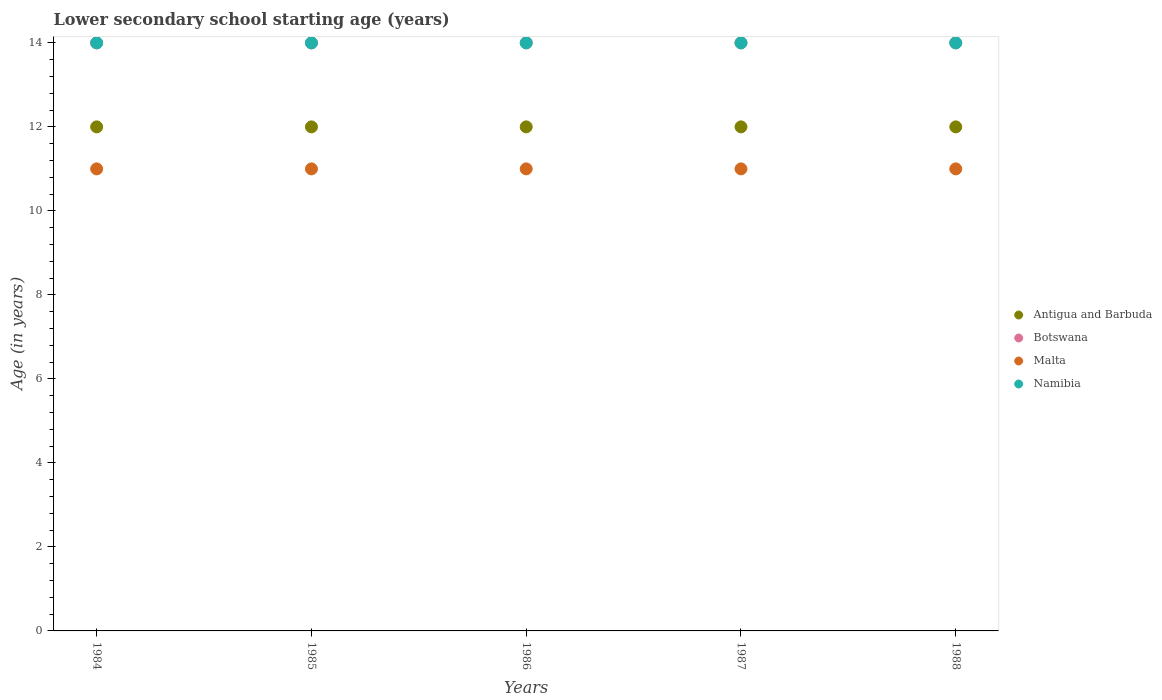Is the number of dotlines equal to the number of legend labels?
Offer a terse response. Yes. Across all years, what is the maximum lower secondary school starting age of children in Botswana?
Your answer should be compact. 14. Across all years, what is the minimum lower secondary school starting age of children in Antigua and Barbuda?
Your answer should be compact. 12. In which year was the lower secondary school starting age of children in Botswana minimum?
Make the answer very short. 1984. What is the total lower secondary school starting age of children in Botswana in the graph?
Your response must be concise. 70. What is the difference between the lower secondary school starting age of children in Botswana in 1985 and that in 1988?
Your answer should be very brief. 0. What is the difference between the lower secondary school starting age of children in Malta in 1984 and the lower secondary school starting age of children in Namibia in 1988?
Offer a terse response. -3. In the year 1988, what is the difference between the lower secondary school starting age of children in Botswana and lower secondary school starting age of children in Namibia?
Offer a very short reply. 0. Is the lower secondary school starting age of children in Botswana in 1984 less than that in 1985?
Ensure brevity in your answer.  No. Is the difference between the lower secondary school starting age of children in Botswana in 1986 and 1987 greater than the difference between the lower secondary school starting age of children in Namibia in 1986 and 1987?
Provide a short and direct response. No. In how many years, is the lower secondary school starting age of children in Namibia greater than the average lower secondary school starting age of children in Namibia taken over all years?
Your answer should be very brief. 0. Is the sum of the lower secondary school starting age of children in Malta in 1987 and 1988 greater than the maximum lower secondary school starting age of children in Botswana across all years?
Your response must be concise. Yes. Is it the case that in every year, the sum of the lower secondary school starting age of children in Malta and lower secondary school starting age of children in Botswana  is greater than the lower secondary school starting age of children in Antigua and Barbuda?
Your answer should be compact. Yes. Is the lower secondary school starting age of children in Malta strictly greater than the lower secondary school starting age of children in Botswana over the years?
Your response must be concise. No. How many dotlines are there?
Offer a very short reply. 4. How many years are there in the graph?
Your answer should be compact. 5. Does the graph contain any zero values?
Keep it short and to the point. No. Does the graph contain grids?
Offer a very short reply. No. Where does the legend appear in the graph?
Your answer should be very brief. Center right. How many legend labels are there?
Your answer should be compact. 4. What is the title of the graph?
Your answer should be very brief. Lower secondary school starting age (years). What is the label or title of the X-axis?
Provide a succinct answer. Years. What is the label or title of the Y-axis?
Make the answer very short. Age (in years). What is the Age (in years) in Botswana in 1984?
Your answer should be compact. 14. What is the Age (in years) of Malta in 1984?
Ensure brevity in your answer.  11. What is the Age (in years) in Namibia in 1984?
Your response must be concise. 14. What is the Age (in years) in Malta in 1985?
Provide a short and direct response. 11. What is the Age (in years) of Namibia in 1985?
Make the answer very short. 14. What is the Age (in years) of Antigua and Barbuda in 1986?
Offer a very short reply. 12. What is the Age (in years) in Botswana in 1986?
Offer a very short reply. 14. What is the Age (in years) in Malta in 1986?
Offer a terse response. 11. What is the Age (in years) in Namibia in 1986?
Offer a terse response. 14. What is the Age (in years) of Antigua and Barbuda in 1987?
Ensure brevity in your answer.  12. What is the Age (in years) in Namibia in 1987?
Ensure brevity in your answer.  14. What is the Age (in years) of Antigua and Barbuda in 1988?
Give a very brief answer. 12. What is the Age (in years) in Namibia in 1988?
Give a very brief answer. 14. Across all years, what is the maximum Age (in years) in Malta?
Your response must be concise. 11. Across all years, what is the maximum Age (in years) of Namibia?
Ensure brevity in your answer.  14. Across all years, what is the minimum Age (in years) in Antigua and Barbuda?
Ensure brevity in your answer.  12. Across all years, what is the minimum Age (in years) of Botswana?
Ensure brevity in your answer.  14. What is the total Age (in years) in Antigua and Barbuda in the graph?
Your answer should be compact. 60. What is the total Age (in years) of Botswana in the graph?
Ensure brevity in your answer.  70. What is the difference between the Age (in years) in Malta in 1984 and that in 1986?
Give a very brief answer. 0. What is the difference between the Age (in years) in Namibia in 1984 and that in 1986?
Offer a terse response. 0. What is the difference between the Age (in years) of Malta in 1984 and that in 1987?
Provide a short and direct response. 0. What is the difference between the Age (in years) in Namibia in 1984 and that in 1987?
Offer a very short reply. 0. What is the difference between the Age (in years) in Namibia in 1984 and that in 1988?
Provide a succinct answer. 0. What is the difference between the Age (in years) of Botswana in 1985 and that in 1986?
Give a very brief answer. 0. What is the difference between the Age (in years) of Antigua and Barbuda in 1985 and that in 1987?
Offer a very short reply. 0. What is the difference between the Age (in years) of Malta in 1985 and that in 1987?
Give a very brief answer. 0. What is the difference between the Age (in years) of Antigua and Barbuda in 1985 and that in 1988?
Ensure brevity in your answer.  0. What is the difference between the Age (in years) in Antigua and Barbuda in 1986 and that in 1987?
Offer a very short reply. 0. What is the difference between the Age (in years) of Botswana in 1986 and that in 1987?
Your answer should be compact. 0. What is the difference between the Age (in years) in Namibia in 1986 and that in 1987?
Give a very brief answer. 0. What is the difference between the Age (in years) in Antigua and Barbuda in 1986 and that in 1988?
Provide a succinct answer. 0. What is the difference between the Age (in years) of Botswana in 1986 and that in 1988?
Give a very brief answer. 0. What is the difference between the Age (in years) in Botswana in 1987 and that in 1988?
Keep it short and to the point. 0. What is the difference between the Age (in years) in Malta in 1987 and that in 1988?
Make the answer very short. 0. What is the difference between the Age (in years) of Antigua and Barbuda in 1984 and the Age (in years) of Botswana in 1985?
Provide a succinct answer. -2. What is the difference between the Age (in years) of Antigua and Barbuda in 1984 and the Age (in years) of Namibia in 1985?
Offer a terse response. -2. What is the difference between the Age (in years) in Botswana in 1984 and the Age (in years) in Malta in 1985?
Give a very brief answer. 3. What is the difference between the Age (in years) in Malta in 1984 and the Age (in years) in Namibia in 1985?
Your answer should be very brief. -3. What is the difference between the Age (in years) of Antigua and Barbuda in 1984 and the Age (in years) of Botswana in 1986?
Your response must be concise. -2. What is the difference between the Age (in years) of Antigua and Barbuda in 1984 and the Age (in years) of Malta in 1986?
Your answer should be very brief. 1. What is the difference between the Age (in years) in Antigua and Barbuda in 1984 and the Age (in years) in Namibia in 1986?
Make the answer very short. -2. What is the difference between the Age (in years) of Botswana in 1984 and the Age (in years) of Namibia in 1986?
Provide a succinct answer. 0. What is the difference between the Age (in years) of Malta in 1984 and the Age (in years) of Namibia in 1986?
Your answer should be compact. -3. What is the difference between the Age (in years) in Antigua and Barbuda in 1984 and the Age (in years) in Malta in 1987?
Keep it short and to the point. 1. What is the difference between the Age (in years) in Antigua and Barbuda in 1984 and the Age (in years) in Namibia in 1987?
Your answer should be compact. -2. What is the difference between the Age (in years) in Antigua and Barbuda in 1984 and the Age (in years) in Malta in 1988?
Your answer should be compact. 1. What is the difference between the Age (in years) in Antigua and Barbuda in 1984 and the Age (in years) in Namibia in 1988?
Offer a very short reply. -2. What is the difference between the Age (in years) in Botswana in 1984 and the Age (in years) in Malta in 1988?
Your answer should be compact. 3. What is the difference between the Age (in years) in Malta in 1984 and the Age (in years) in Namibia in 1988?
Your answer should be very brief. -3. What is the difference between the Age (in years) of Antigua and Barbuda in 1985 and the Age (in years) of Malta in 1986?
Your answer should be very brief. 1. What is the difference between the Age (in years) in Botswana in 1985 and the Age (in years) in Namibia in 1986?
Make the answer very short. 0. What is the difference between the Age (in years) in Malta in 1985 and the Age (in years) in Namibia in 1986?
Offer a very short reply. -3. What is the difference between the Age (in years) in Antigua and Barbuda in 1985 and the Age (in years) in Botswana in 1987?
Offer a very short reply. -2. What is the difference between the Age (in years) in Antigua and Barbuda in 1985 and the Age (in years) in Malta in 1987?
Your answer should be compact. 1. What is the difference between the Age (in years) of Antigua and Barbuda in 1985 and the Age (in years) of Namibia in 1987?
Give a very brief answer. -2. What is the difference between the Age (in years) in Botswana in 1985 and the Age (in years) in Namibia in 1987?
Your answer should be very brief. 0. What is the difference between the Age (in years) in Malta in 1985 and the Age (in years) in Namibia in 1987?
Offer a very short reply. -3. What is the difference between the Age (in years) of Antigua and Barbuda in 1985 and the Age (in years) of Botswana in 1988?
Ensure brevity in your answer.  -2. What is the difference between the Age (in years) in Botswana in 1985 and the Age (in years) in Namibia in 1988?
Make the answer very short. 0. What is the difference between the Age (in years) of Antigua and Barbuda in 1986 and the Age (in years) of Malta in 1987?
Keep it short and to the point. 1. What is the difference between the Age (in years) of Botswana in 1986 and the Age (in years) of Malta in 1987?
Your answer should be very brief. 3. What is the difference between the Age (in years) of Antigua and Barbuda in 1986 and the Age (in years) of Botswana in 1988?
Your answer should be very brief. -2. What is the difference between the Age (in years) in Antigua and Barbuda in 1986 and the Age (in years) in Namibia in 1988?
Keep it short and to the point. -2. What is the difference between the Age (in years) of Malta in 1986 and the Age (in years) of Namibia in 1988?
Give a very brief answer. -3. What is the difference between the Age (in years) in Antigua and Barbuda in 1987 and the Age (in years) in Malta in 1988?
Your answer should be very brief. 1. What is the difference between the Age (in years) of Antigua and Barbuda in 1987 and the Age (in years) of Namibia in 1988?
Your answer should be compact. -2. What is the difference between the Age (in years) in Botswana in 1987 and the Age (in years) in Namibia in 1988?
Keep it short and to the point. 0. What is the average Age (in years) of Botswana per year?
Your answer should be very brief. 14. What is the average Age (in years) of Namibia per year?
Keep it short and to the point. 14. In the year 1984, what is the difference between the Age (in years) of Antigua and Barbuda and Age (in years) of Malta?
Offer a terse response. 1. In the year 1985, what is the difference between the Age (in years) of Antigua and Barbuda and Age (in years) of Botswana?
Your answer should be compact. -2. In the year 1985, what is the difference between the Age (in years) of Botswana and Age (in years) of Malta?
Keep it short and to the point. 3. In the year 1985, what is the difference between the Age (in years) in Botswana and Age (in years) in Namibia?
Provide a succinct answer. 0. In the year 1986, what is the difference between the Age (in years) of Antigua and Barbuda and Age (in years) of Botswana?
Your response must be concise. -2. In the year 1986, what is the difference between the Age (in years) in Malta and Age (in years) in Namibia?
Provide a succinct answer. -3. In the year 1987, what is the difference between the Age (in years) in Antigua and Barbuda and Age (in years) in Botswana?
Make the answer very short. -2. In the year 1987, what is the difference between the Age (in years) in Antigua and Barbuda and Age (in years) in Malta?
Provide a short and direct response. 1. In the year 1987, what is the difference between the Age (in years) of Botswana and Age (in years) of Malta?
Your answer should be compact. 3. In the year 1987, what is the difference between the Age (in years) of Malta and Age (in years) of Namibia?
Ensure brevity in your answer.  -3. In the year 1988, what is the difference between the Age (in years) in Antigua and Barbuda and Age (in years) in Botswana?
Your response must be concise. -2. In the year 1988, what is the difference between the Age (in years) of Antigua and Barbuda and Age (in years) of Namibia?
Ensure brevity in your answer.  -2. In the year 1988, what is the difference between the Age (in years) of Botswana and Age (in years) of Malta?
Give a very brief answer. 3. What is the ratio of the Age (in years) in Botswana in 1984 to that in 1985?
Ensure brevity in your answer.  1. What is the ratio of the Age (in years) in Antigua and Barbuda in 1984 to that in 1986?
Ensure brevity in your answer.  1. What is the ratio of the Age (in years) of Malta in 1984 to that in 1986?
Ensure brevity in your answer.  1. What is the ratio of the Age (in years) of Antigua and Barbuda in 1984 to that in 1987?
Your response must be concise. 1. What is the ratio of the Age (in years) in Botswana in 1984 to that in 1987?
Ensure brevity in your answer.  1. What is the ratio of the Age (in years) of Botswana in 1984 to that in 1988?
Ensure brevity in your answer.  1. What is the ratio of the Age (in years) of Malta in 1984 to that in 1988?
Ensure brevity in your answer.  1. What is the ratio of the Age (in years) in Antigua and Barbuda in 1985 to that in 1986?
Give a very brief answer. 1. What is the ratio of the Age (in years) of Namibia in 1985 to that in 1986?
Your answer should be very brief. 1. What is the ratio of the Age (in years) in Botswana in 1986 to that in 1987?
Your answer should be very brief. 1. What is the ratio of the Age (in years) in Malta in 1986 to that in 1987?
Your response must be concise. 1. What is the ratio of the Age (in years) in Namibia in 1986 to that in 1987?
Your answer should be very brief. 1. What is the ratio of the Age (in years) in Antigua and Barbuda in 1986 to that in 1988?
Ensure brevity in your answer.  1. What is the ratio of the Age (in years) of Antigua and Barbuda in 1987 to that in 1988?
Your answer should be compact. 1. What is the ratio of the Age (in years) in Namibia in 1987 to that in 1988?
Offer a terse response. 1. What is the difference between the highest and the second highest Age (in years) in Antigua and Barbuda?
Provide a succinct answer. 0. What is the difference between the highest and the second highest Age (in years) of Namibia?
Your answer should be compact. 0. What is the difference between the highest and the lowest Age (in years) of Antigua and Barbuda?
Ensure brevity in your answer.  0. What is the difference between the highest and the lowest Age (in years) in Malta?
Provide a succinct answer. 0. What is the difference between the highest and the lowest Age (in years) of Namibia?
Make the answer very short. 0. 